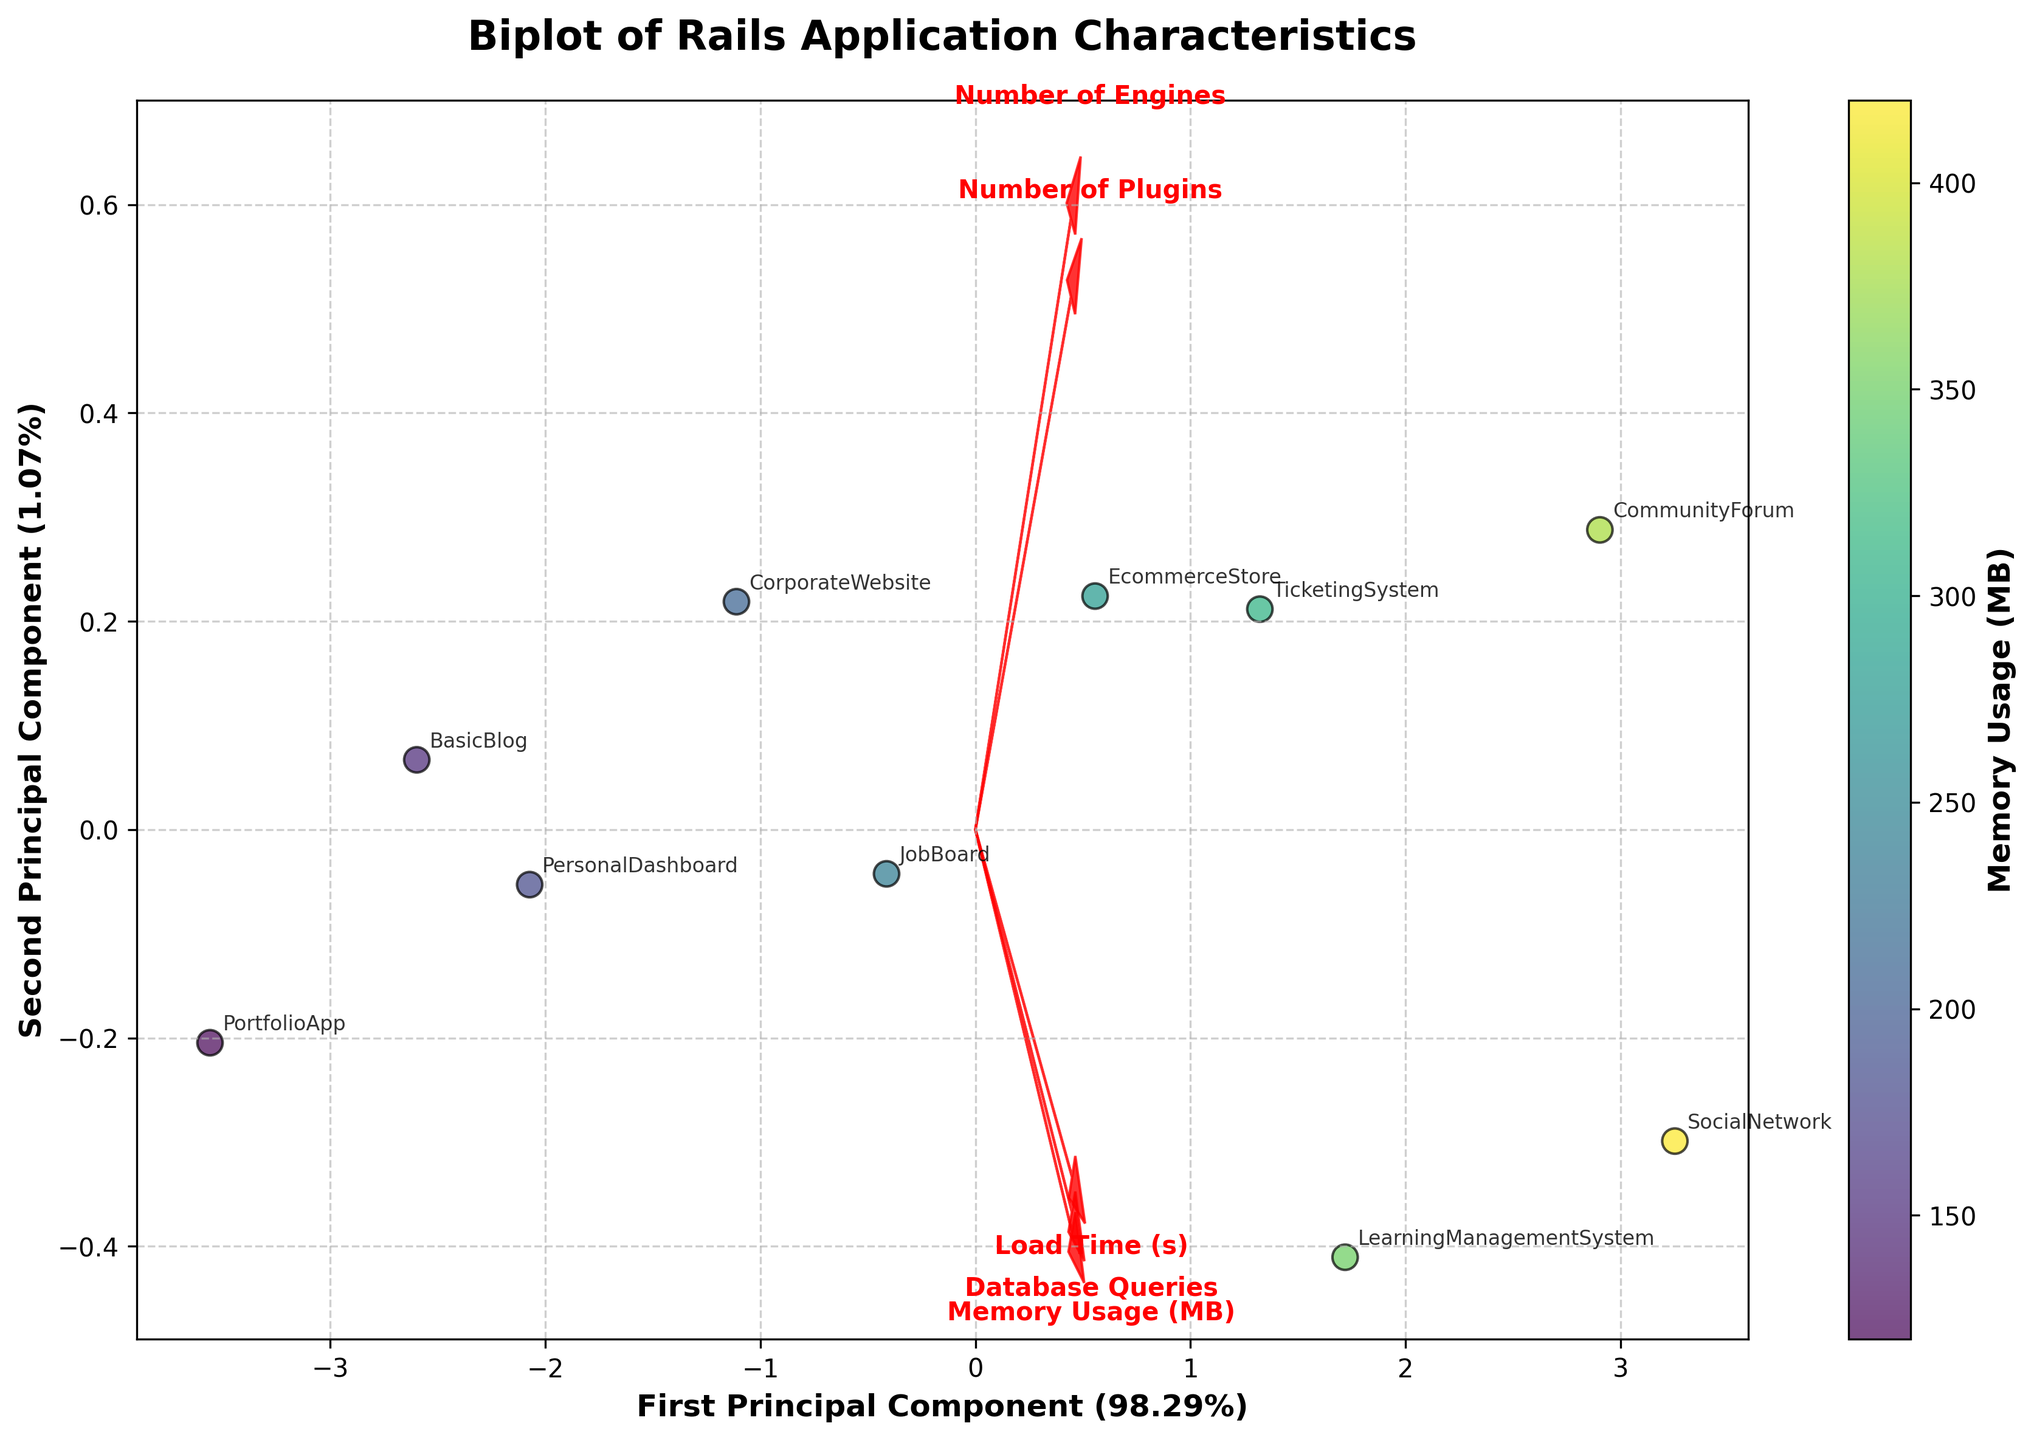How many data points are plotted on the biplot? To determine the number of data points, count the number of instances of application labels on the plot. The data contains 10 applications, so there should be 10 data points on the biplot, each represented by a scatter point.
Answer: 10 Which application has the highest load time? Identify the application point that aligns most positively with the arrow representing 'Load Time (s)'. The application "SocialNetwork" is furthest along this vector, indicating the highest load time.
Answer: SocialNetwork What are the X and Y-axis labels? The labels of the axes can be read directly from the figure. The X-axis label is 'First Principal Component' and the Y-axis label is 'Second Principal Component'. They also include the percentage of variance explained.
Answer: First Principal Component, Second Principal Component How is the color of data points determined? The color of the data points correlates with the 'Memory Usage (MB)' as indicated by the colorbar on the right side of the plot. Darker colors represent higher memory usage.
Answer: Memory Usage (MB) Which applications have almost the same load time but different memory usage? Look for application points that lie close to each other along the 'Load Time (s)' vector but have notably different colors (memory usage). "CorporateWebsite" and "JobBoard" are examples; both have similar load times but differ in memory usage as indicated by their colors.
Answer: CorporateWebsite, JobBoard Does 'Number of Engines' have a strong influence on the applications' characteristics? Check the length and direction of the 'Number of Engines' vector. A long arrow indicates a stronger influence. The 'Number of Engines' vector is relatively long and pointed towards many application points, indicating a strong influence.
Answer: Yes Which principal component explains more variance in the data? Compare the percentage values shown in the labels of the 'First Principal Component' and 'Second Principal Component'. The 'First Principal Component' has a higher percentage.
Answer: First Principal Component Do applications with higher database queries generally have more engines or plugins? Check the directions of 'Database Queries', 'Number of Engines', and 'Number of Plugins' vectors. Applications with higher 'Database Queries' tend to align positively with both 'Number of Engines' and 'Number of Plugins' vectors, indicating a general trend of having more engines and plugins.
Answer: Yes What is the relationship between load time and memory usage from the plot? Observe the direction and alignment of the 'Load Time (s)' and 'Memory Usage (MB)' vectors. They point in generally similar directions, suggesting that higher load times are associated with higher memory usage.
Answer: Higher load time, higher memory usage Which feature vector points in a completely different direction from 'Load Time (s)'? Check the vectors that have an opposite direction to 'Load Time (s)'. The 'Number of Engines' vector points almost opposite to 'Load Time (s)', indicating a negative relationship.
Answer: Number of Engines 